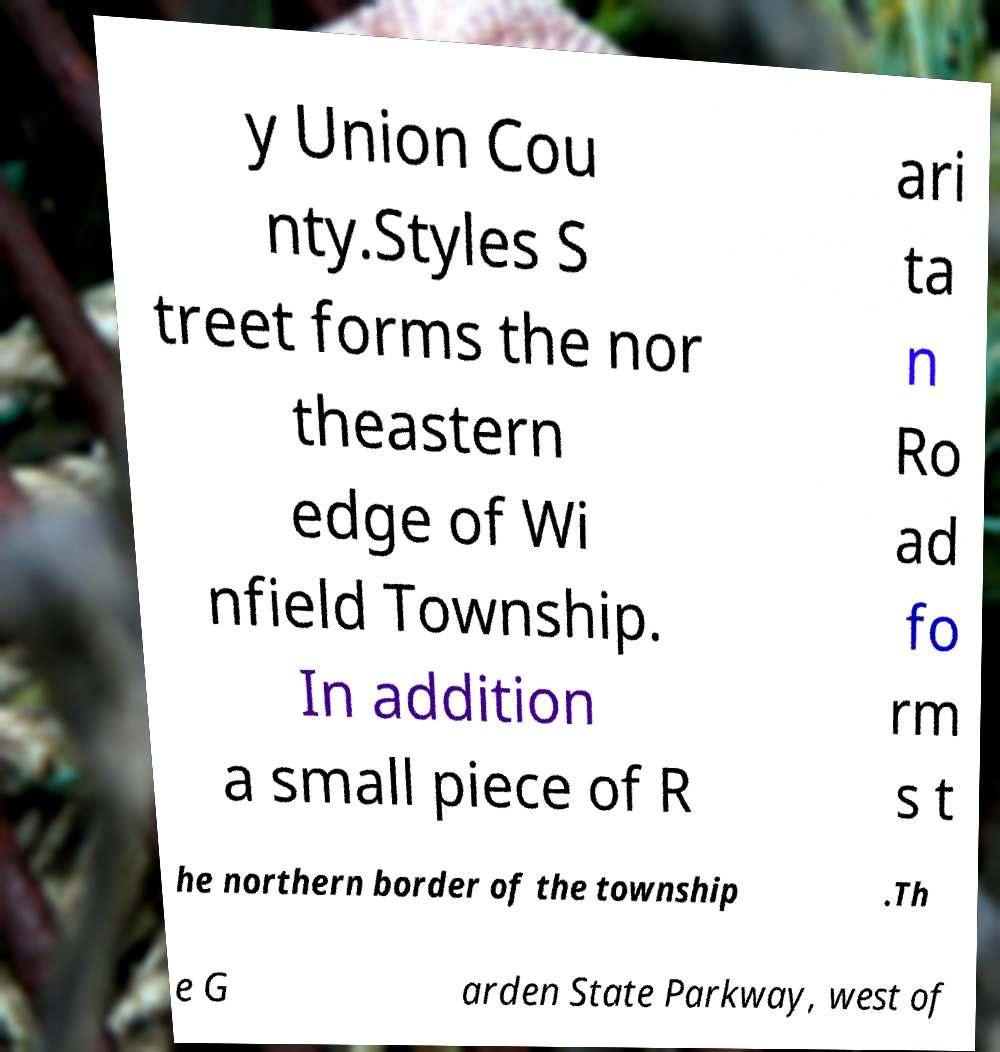Could you assist in decoding the text presented in this image and type it out clearly? y Union Cou nty.Styles S treet forms the nor theastern edge of Wi nfield Township. In addition a small piece of R ari ta n Ro ad fo rm s t he northern border of the township .Th e G arden State Parkway, west of 